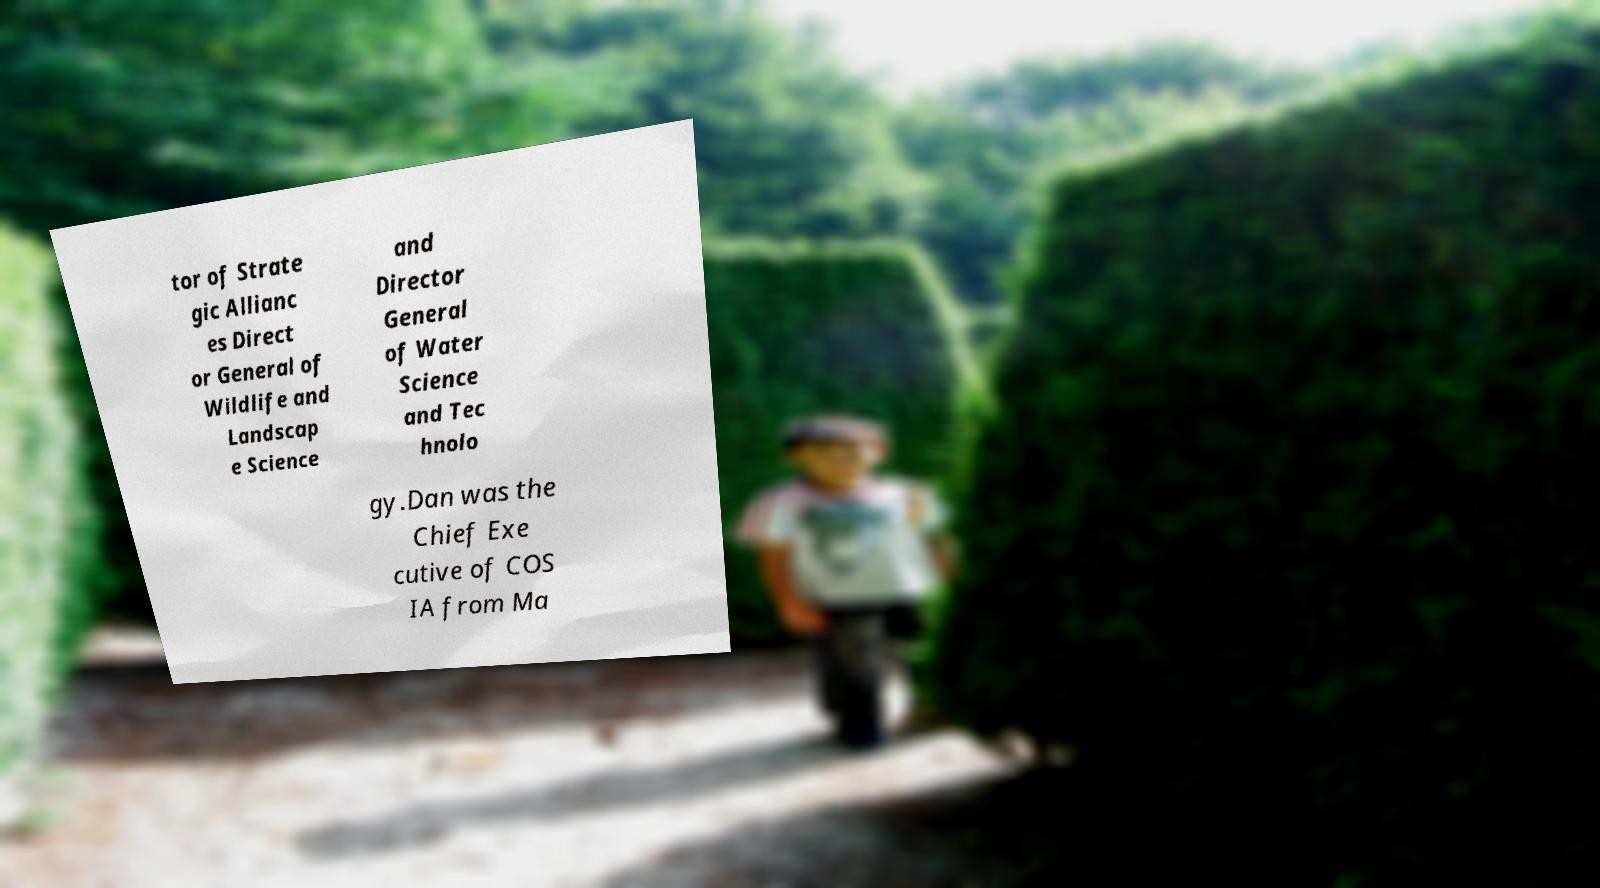Could you extract and type out the text from this image? tor of Strate gic Allianc es Direct or General of Wildlife and Landscap e Science and Director General of Water Science and Tec hnolo gy.Dan was the Chief Exe cutive of COS IA from Ma 